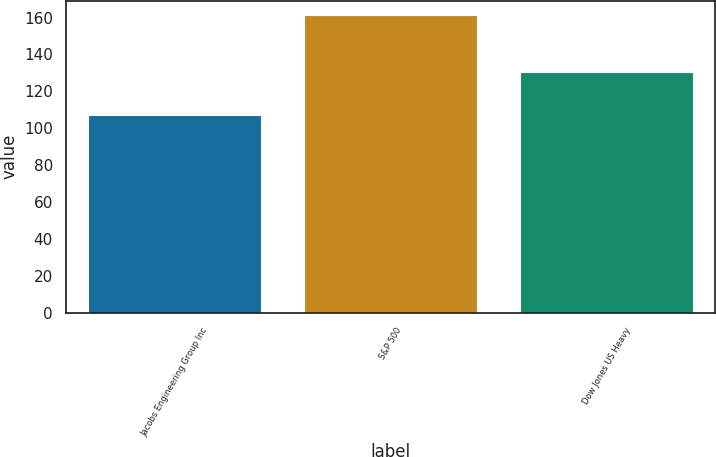<chart> <loc_0><loc_0><loc_500><loc_500><bar_chart><fcel>Jacobs Engineering Group Inc<fcel>S&P 500<fcel>Dow Jones US Heavy<nl><fcel>107.13<fcel>161.17<fcel>130.35<nl></chart> 